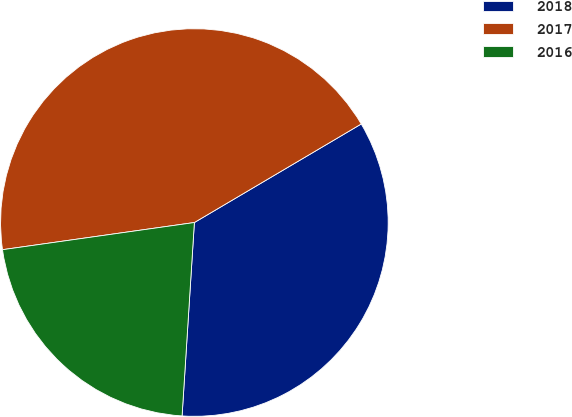Convert chart to OTSL. <chart><loc_0><loc_0><loc_500><loc_500><pie_chart><fcel>2018<fcel>2017<fcel>2016<nl><fcel>34.5%<fcel>43.75%<fcel>21.75%<nl></chart> 